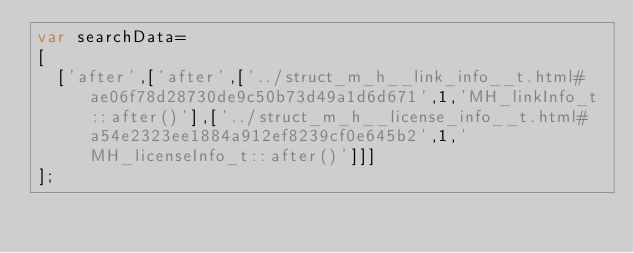<code> <loc_0><loc_0><loc_500><loc_500><_JavaScript_>var searchData=
[
  ['after',['after',['../struct_m_h__link_info__t.html#ae06f78d28730de9c50b73d49a1d6d671',1,'MH_linkInfo_t::after()'],['../struct_m_h__license_info__t.html#a54e2323ee1884a912ef8239cf0e645b2',1,'MH_licenseInfo_t::after()']]]
];
</code> 